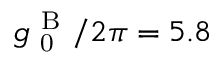<formula> <loc_0><loc_0><loc_500><loc_500>g _ { 0 } ^ { B } / 2 \pi = 5 . 8</formula> 